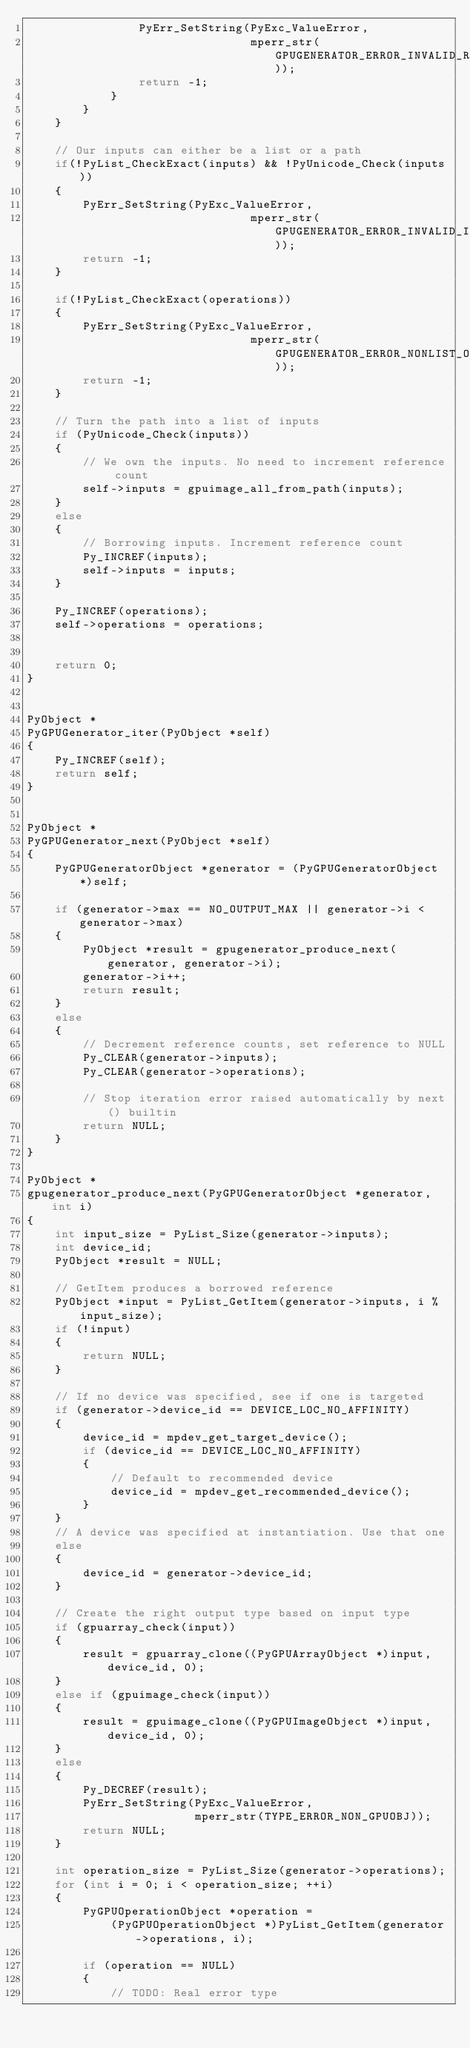<code> <loc_0><loc_0><loc_500><loc_500><_C_>                PyErr_SetString(PyExc_ValueError,
                                mperr_str(GPUGENERATOR_ERROR_INVALID_RETURN_TO));
                return -1;
            }
        }
    }

    // Our inputs can either be a list or a path
    if(!PyList_CheckExact(inputs) && !PyUnicode_Check(inputs))
    {
        PyErr_SetString(PyExc_ValueError,
                                mperr_str(GPUGENERATOR_ERROR_INVALID_INPUT));
        return -1;
    }

    if(!PyList_CheckExact(operations))
    {
        PyErr_SetString(PyExc_ValueError,
                                mperr_str(GPUGENERATOR_ERROR_NONLIST_OPERATIONS));
        return -1;
    }

    // Turn the path into a list of inputs
    if (PyUnicode_Check(inputs))
    {
        // We own the inputs. No need to increment reference count
        self->inputs = gpuimage_all_from_path(inputs);
    }
    else
    {
        // Borrowing inputs. Increment reference count
        Py_INCREF(inputs);
        self->inputs = inputs;
    }

    Py_INCREF(operations);
    self->operations = operations;
    

    return 0;
}


PyObject *
PyGPUGenerator_iter(PyObject *self)
{
    Py_INCREF(self);
    return self;
}


PyObject *
PyGPUGenerator_next(PyObject *self)
{
    PyGPUGeneratorObject *generator = (PyGPUGeneratorObject *)self;

    if (generator->max == NO_OUTPUT_MAX || generator->i < generator->max)
    {
        PyObject *result = gpugenerator_produce_next(generator, generator->i);
        generator->i++;
        return result;
    }
    else
    {
        // Decrement reference counts, set reference to NULL
        Py_CLEAR(generator->inputs);
        Py_CLEAR(generator->operations);

        // Stop iteration error raised automatically by next() builtin
        return NULL;
    }
}

PyObject *
gpugenerator_produce_next(PyGPUGeneratorObject *generator, int i)
{
    int input_size = PyList_Size(generator->inputs);
    int device_id;
    PyObject *result = NULL;

    // GetItem produces a borrowed reference
    PyObject *input = PyList_GetItem(generator->inputs, i % input_size);
    if (!input)
    {
        return NULL;
    }

    // If no device was specified, see if one is targeted
    if (generator->device_id == DEVICE_LOC_NO_AFFINITY)
    {
        device_id = mpdev_get_target_device();
        if (device_id == DEVICE_LOC_NO_AFFINITY)
        {
            // Default to recommended device
            device_id = mpdev_get_recommended_device();
        }
    }
    // A device was specified at instantiation. Use that one
    else
    {
        device_id = generator->device_id;
    }

    // Create the right output type based on input type
    if (gpuarray_check(input))
    {
        result = gpuarray_clone((PyGPUArrayObject *)input, device_id, 0);
    }
    else if (gpuimage_check(input))
    {
        result = gpuimage_clone((PyGPUImageObject *)input, device_id, 0);
    }
    else
    {
        Py_DECREF(result);
        PyErr_SetString(PyExc_ValueError,
                        mperr_str(TYPE_ERROR_NON_GPUOBJ));
        return NULL;
    }

    int operation_size = PyList_Size(generator->operations);
    for (int i = 0; i < operation_size; ++i)
    {   
        PyGPUOperationObject *operation =
            (PyGPUOperationObject *)PyList_GetItem(generator->operations, i);

        if (operation == NULL)
        {
            // TODO: Real error type</code> 